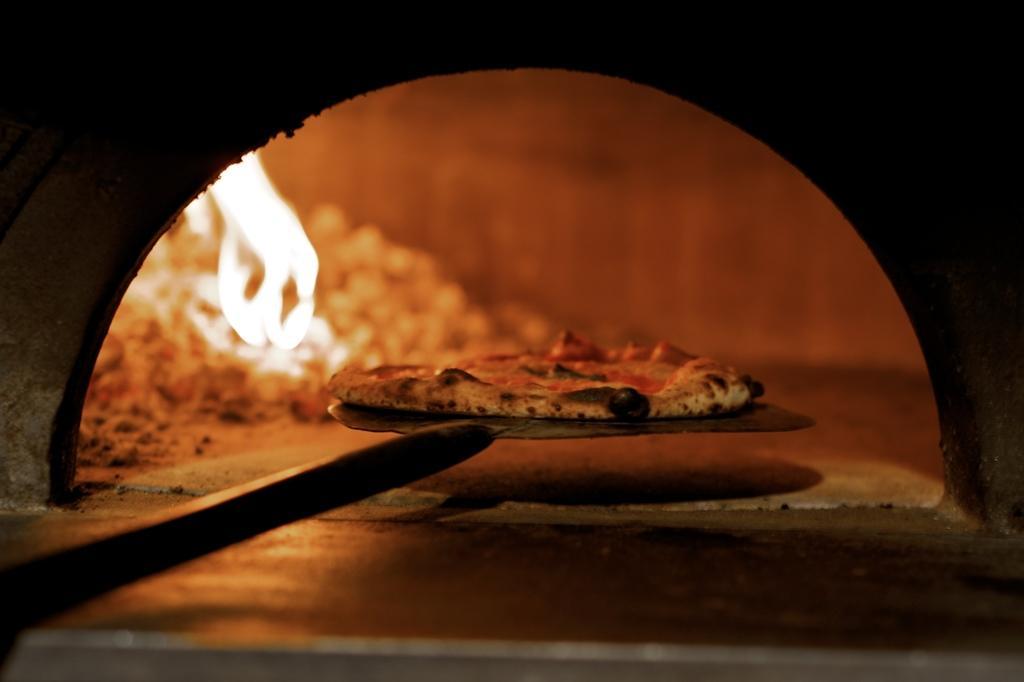Describe this image in one or two sentences. In this image we can see a pie on a large spatula. On the backside we can see some fire. 